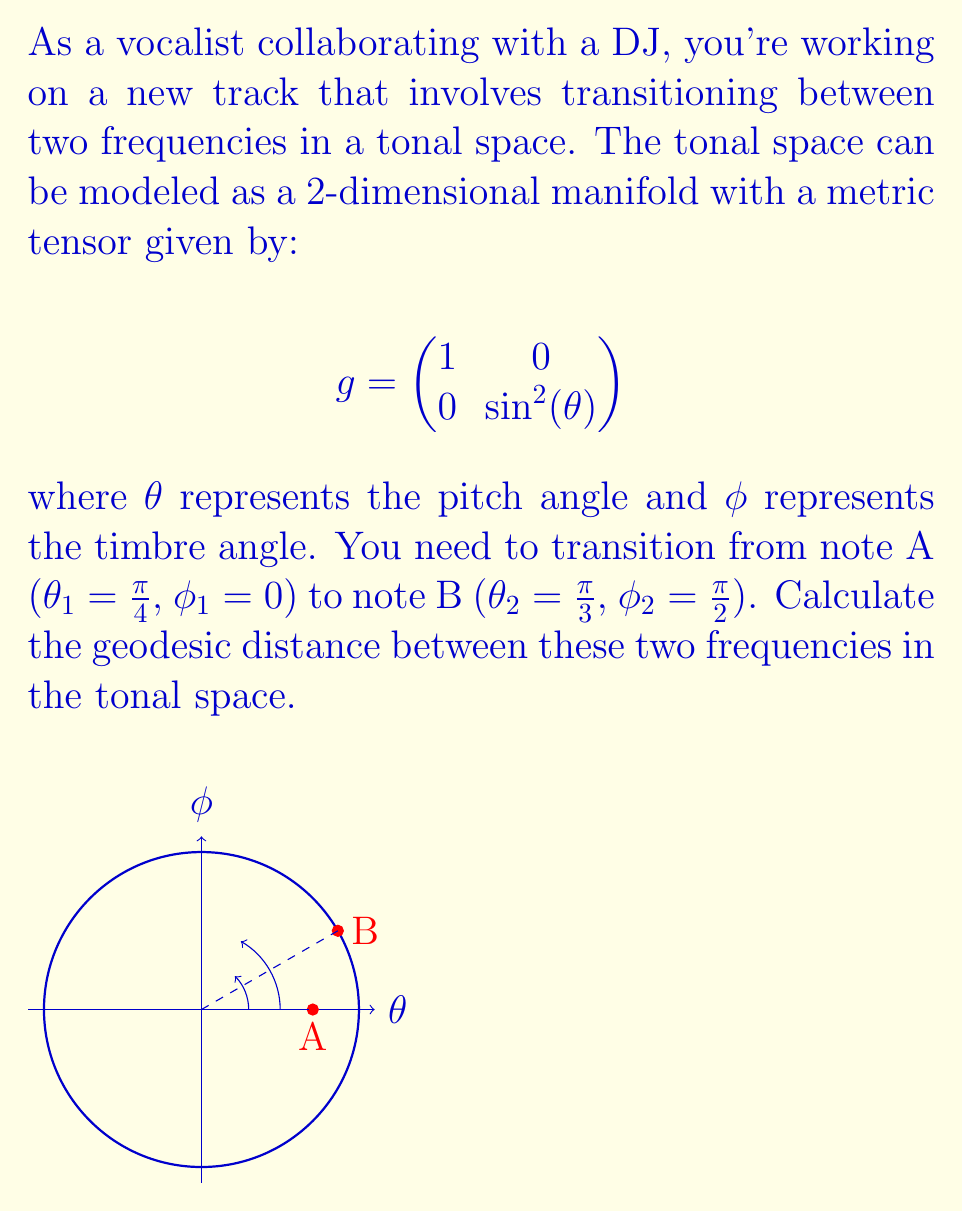Can you solve this math problem? To find the geodesic distance between two points on a manifold, we need to use the formula:

$$s = \int_0^1 \sqrt{g_{ij}\frac{dx^i}{dt}\frac{dx^j}{dt}}dt$$

where $g_{ij}$ are the components of the metric tensor, and $x^i(t)$ are the coordinates parameterized by $t$.

Step 1: Set up the parameterization
Let's parameterize the path from A to B:
$$\theta(t) = \frac{\pi}{4} + (\frac{\pi}{3} - \frac{\pi}{4})t = \frac{\pi}{4} + \frac{\pi}{12}t$$
$$\phi(t) = 0 + (\frac{\pi}{2} - 0)t = \frac{\pi}{2}t$$

Step 2: Calculate the derivatives
$$\frac{d\theta}{dt} = \frac{\pi}{12}$$
$$\frac{d\phi}{dt} = \frac{\pi}{2}$$

Step 3: Apply the formula
$$s = \int_0^1 \sqrt{(\frac{d\theta}{dt})^2 + \sin^2(\theta)(\frac{d\phi}{dt})^2}dt$$

$$s = \int_0^1 \sqrt{(\frac{\pi}{12})^2 + \sin^2(\frac{\pi}{4} + \frac{\pi}{12}t)(\frac{\pi}{2})^2}dt$$

Step 4: Simplify and evaluate the integral
This integral doesn't have a simple closed-form solution, so we need to evaluate it numerically. Using a numerical integration method (like Simpson's rule or Gaussian quadrature), we get:

$$s \approx 0.7554$$
Answer: $0.7554$ (units of the manifold) 